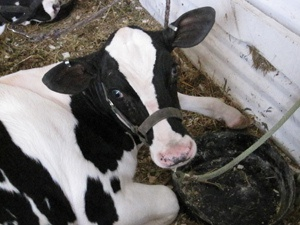Describe the objects in this image and their specific colors. I can see a cow in black, lightgray, darkgray, and gray tones in this image. 